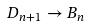Convert formula to latex. <formula><loc_0><loc_0><loc_500><loc_500>D _ { n + 1 } \rightarrow B _ { n }</formula> 